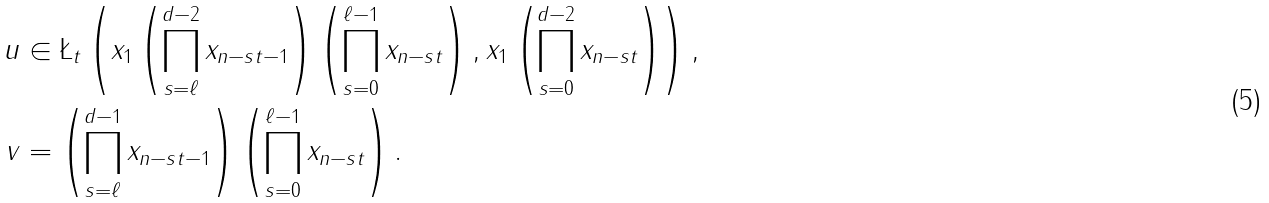Convert formula to latex. <formula><loc_0><loc_0><loc_500><loc_500>u & \in \L _ { t } \left ( x _ { 1 } \left ( \prod _ { s = \ell } ^ { d - 2 } x _ { n - s t - 1 } \right ) \left ( \prod _ { s = 0 } ^ { \ell - 1 } x _ { n - s t } \right ) , x _ { 1 } \left ( \prod _ { s = 0 } ^ { d - 2 } x _ { n - s t } \right ) \right ) , \\ v & = \left ( \prod _ { s = \ell } ^ { d - 1 } x _ { n - s t - 1 } \right ) \left ( \prod _ { s = 0 } ^ { \ell - 1 } x _ { n - s t } \right ) .</formula> 